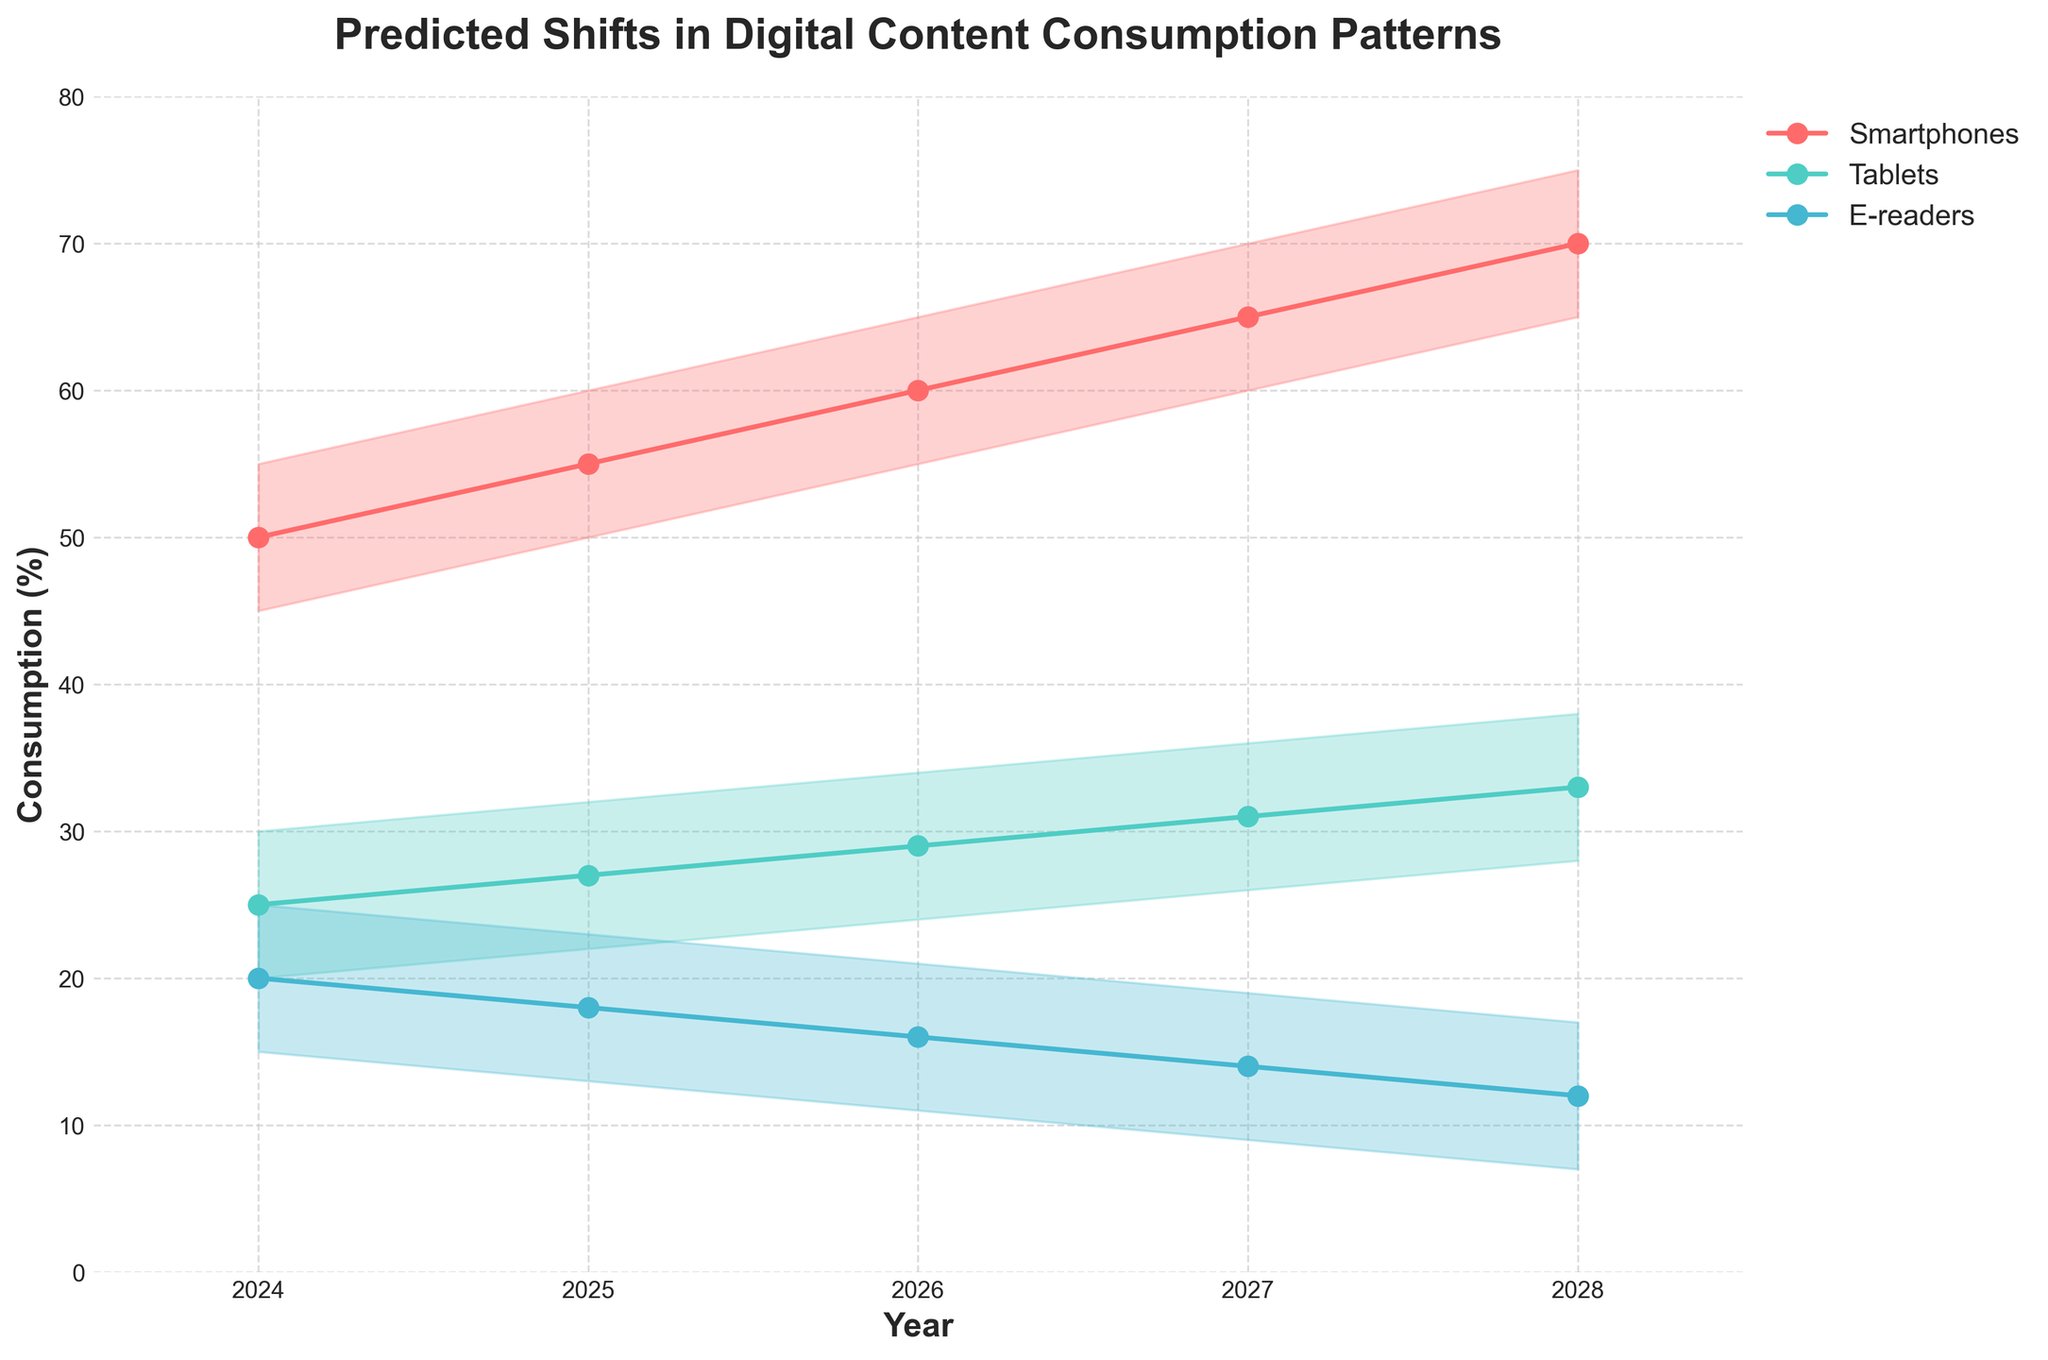What is the title of the chart? The title of the chart is located at the top of the figure. It is usually a descriptive summary of what the figure represents.
Answer: Predicted Shifts in Digital Content Consumption Patterns What is the expected digital content consumption on smartphones in 2025? Locate the year 2025 along the x-axis and then find the corresponding point on the line labeled "Smartphones". The y-axis value at this point indicates the expected consumption.
Answer: 55% Which platform is predicted to have the lowest content consumption in 2028? Compare the expected consumption values for all platforms in 2028. E-readers have the lowest expected consumption.
Answer: E-readers How does the expected consumption trend for tablets change from 2024 to 2028? Follow the expected consumption line for tablets from 2024 to 2028. Note the general direction and magnitude of the change. It shows an increasing trend.
Answer: Increasing What is the range of predicted consumption for e-readers in 2026? Find the year 2026 on the x-axis and then look at the shaded area for e-readers. The range is between the "Low" and "High" values.
Answer: 11% to 21% By how much is the expected consumption for smartphones predicted to increase from 2024 to 2027? Subtract the expected value for smartphones in 2024 from the expected value in 2027.
Answer: 65% - 50% = 15% Which platform has the steepest increase in expected consumption over the years shown? Compare the slopes of the expected consumption lines for all platforms. The steepest line indicates the platform with the most rapid increase.
Answer: Smartphones What is the difference between the high and low predicted consumption values for tablets in 2028? Subtract the low value from the high value for tablets in the year 2028.
Answer: 38% - 28% = 10% Between which two consecutive years is the largest increase in expected e-reader consumption projected? Compare the differences in expected e-reader consumption between consecutive years. Identify the pair of years with the largest increase.
Answer: No consecutive increase; all values decrease Is any platform predicted to have a decrease in their expected consumption over the years? Look at the trend lines of the expected consumption for each platform and note if any line decreases. E-readers show a decreasing trend.
Answer: E-readers 